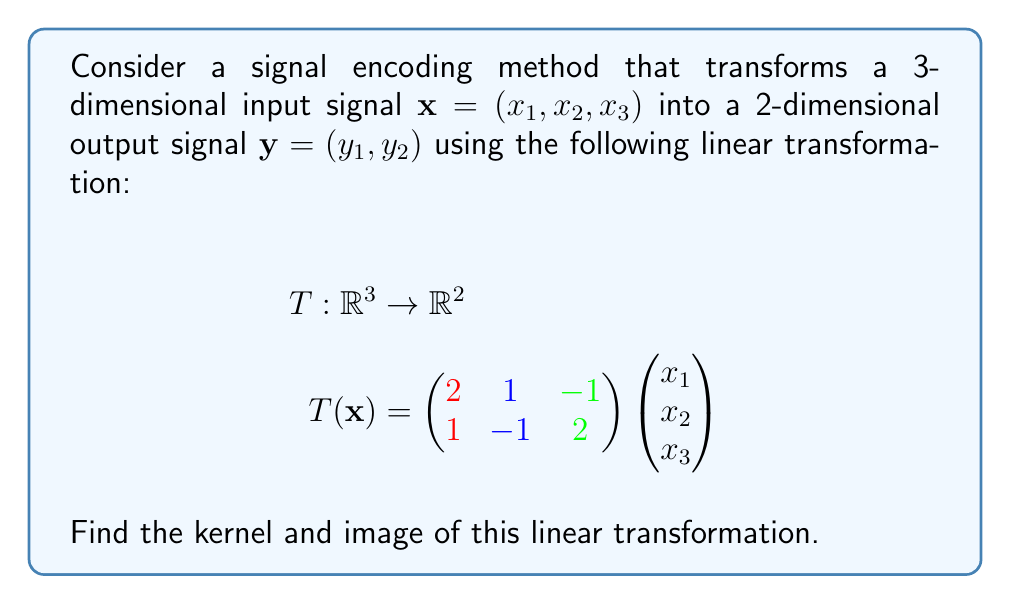Solve this math problem. To find the kernel and image of the linear transformation T, we'll follow these steps:

1. Find the kernel:
   The kernel of T consists of all vectors $\mathbf{x}$ such that $T(\mathbf{x}) = \mathbf{0}$.
   
   $$\begin{pmatrix} 2 & 1 & -1 \\ 1 & -1 & 2 \end{pmatrix} \begin{pmatrix} x_1 \\ x_2 \\ x_3 \end{pmatrix} = \begin{pmatrix} 0 \\ 0 \end{pmatrix}$$
   
   This gives us the system of equations:
   $$2x_1 + x_2 - x_3 = 0$$
   $$x_1 - x_2 + 2x_3 = 0$$
   
   Solving this system:
   From the first equation: $x_2 = -2x_1 + x_3$
   Substituting into the second equation:
   $$x_1 - (-2x_1 + x_3) + 2x_3 = 0$$
   $$3x_1 - x_3 = 0$$
   $$x_1 = \frac{1}{3}x_3$$
   
   Therefore, the general solution is:
   $$\mathbf{x} = x_3 \begin{pmatrix} 1/3 \\ -1/3 \\ 1 \end{pmatrix}$$
   
   The kernel is a 1-dimensional subspace of $\mathbb{R}^3$.

2. Find the image:
   The image of T is the span of the column vectors of the transformation matrix.
   
   $$\text{Im}(T) = \text{span}\left\{\begin{pmatrix} 2 \\ 1 \end{pmatrix}, \begin{pmatrix} 1 \\ -1 \end{pmatrix}, \begin{pmatrix} -1 \\ 2 \end{pmatrix}\right\}$$
   
   To find the dimension of the image, we need to check the linear independence of these vectors.
   The rank of the matrix is 2 (you can verify this by calculating the determinant of any 2x2 submatrix), so the image is all of $\mathbb{R}^2$.
Answer: Kernel: $\text{span}\left\{\begin{pmatrix} 1/3 \\ -1/3 \\ 1 \end{pmatrix}\right\}$, Image: $\mathbb{R}^2$ 